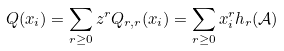<formula> <loc_0><loc_0><loc_500><loc_500>Q ( x _ { i } ) = \sum _ { r \geq 0 } z ^ { r } Q _ { r , r } ( x _ { i } ) = \sum _ { r \geq 0 } x _ { i } ^ { r } h _ { r } ( \mathcal { A } )</formula> 